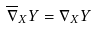Convert formula to latex. <formula><loc_0><loc_0><loc_500><loc_500>\overline { \nabla } _ { X } Y = \nabla _ { X } Y</formula> 